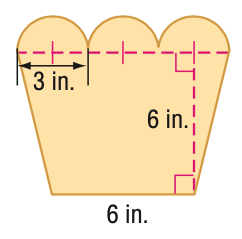Question: Find the area of the figure. Round to the nearest tenth if necessary.
Choices:
A. 55.6
B. 66.2
C. 100.6
D. 111.2
Answer with the letter. Answer: A 